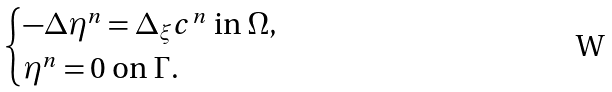<formula> <loc_0><loc_0><loc_500><loc_500>\begin{cases} - \Delta \eta ^ { n } = \Delta _ { \xi } c ^ { n } \text { in $\Omega$,} \\ \eta ^ { n } = 0 \text { on $\Gamma$.} \end{cases}</formula> 